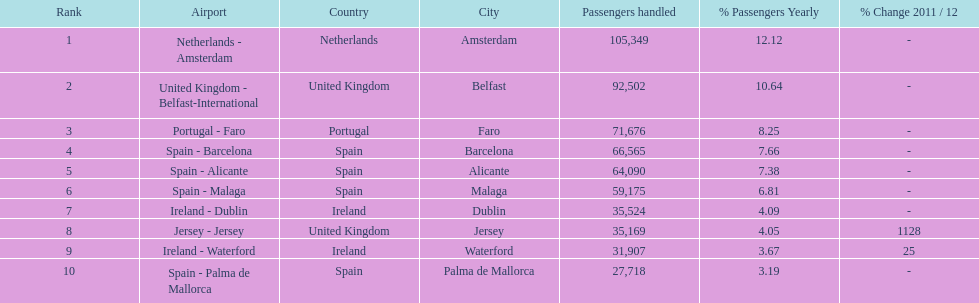How many airports are listed? 10. Could you parse the entire table as a dict? {'header': ['Rank', 'Airport', 'Country', 'City', 'Passengers handled', '% Passengers Yearly', '% Change 2011 / 12'], 'rows': [['1', 'Netherlands - Amsterdam', 'Netherlands', 'Amsterdam', '105,349', '12.12', '-'], ['2', 'United Kingdom - Belfast-International', 'United Kingdom', 'Belfast', '92,502', '10.64', '-'], ['3', 'Portugal - Faro', 'Portugal', 'Faro', '71,676', '8.25', '-'], ['4', 'Spain - Barcelona', 'Spain', 'Barcelona', '66,565', '7.66', '-'], ['5', 'Spain - Alicante', 'Spain', 'Alicante', '64,090', '7.38', '-'], ['6', 'Spain - Malaga', 'Spain', 'Malaga', '59,175', '6.81', '-'], ['7', 'Ireland - Dublin', 'Ireland', 'Dublin', '35,524', '4.09', '-'], ['8', 'Jersey - Jersey', 'United Kingdom', 'Jersey', '35,169', '4.05', '1128'], ['9', 'Ireland - Waterford', 'Ireland', 'Waterford', '31,907', '3.67', '25'], ['10', 'Spain - Palma de Mallorca', 'Spain', 'Palma de Mallorca', '27,718', '3.19', '-']]} 